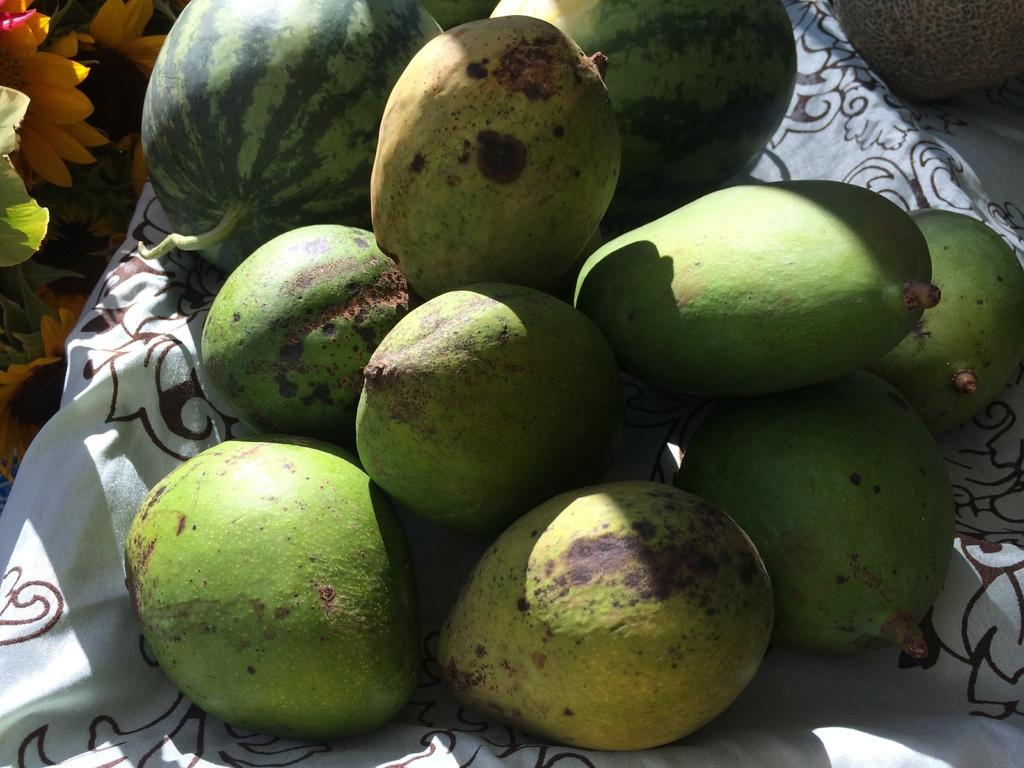What fruits are arranged on the cloth in the image? There are mangoes and watermelons arranged on a cloth in the middle of the image. What can be seen on the left side of the image? There are flowers on the left side of the image. Can you describe the fruit visible in the background of the image? Unfortunately, the provided facts do not mention any specific fruit visible in the background. Where is the toothbrush located in the image? There is no toothbrush present in the image. What type of quilt is covering the fruits in the image? There is no quilt covering the fruits in the image; they are arranged on a cloth. 